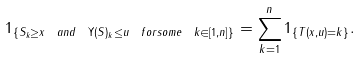Convert formula to latex. <formula><loc_0><loc_0><loc_500><loc_500>1 _ { \{ S _ { k } \geq x \ a n d \ \Upsilon ( S ) _ { k } \leq u \ f o r s o m e \ k \in [ 1 , n ] \} } = \sum _ { k = 1 } ^ { n } 1 _ { \{ T ( x , u ) = k \} } .</formula> 